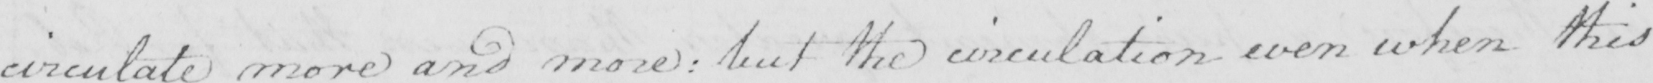Please provide the text content of this handwritten line. circulate more and more :  but the circulation even when this 